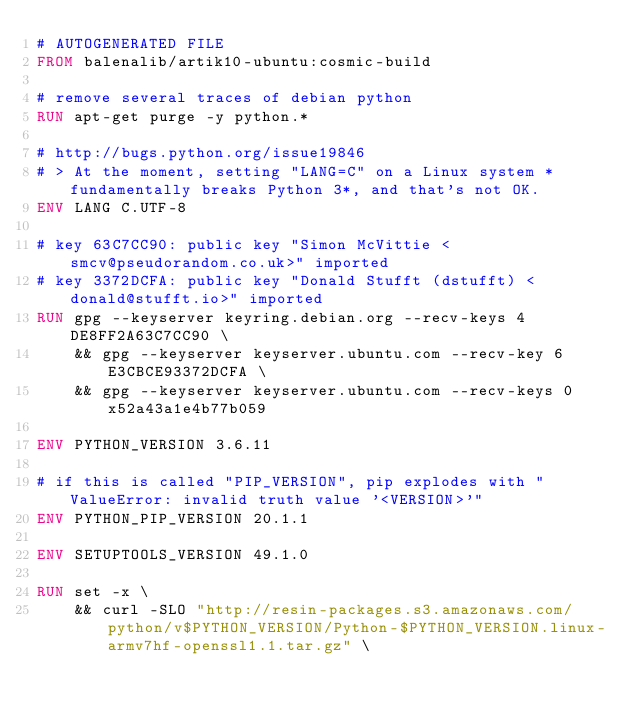Convert code to text. <code><loc_0><loc_0><loc_500><loc_500><_Dockerfile_># AUTOGENERATED FILE
FROM balenalib/artik10-ubuntu:cosmic-build

# remove several traces of debian python
RUN apt-get purge -y python.*

# http://bugs.python.org/issue19846
# > At the moment, setting "LANG=C" on a Linux system *fundamentally breaks Python 3*, and that's not OK.
ENV LANG C.UTF-8

# key 63C7CC90: public key "Simon McVittie <smcv@pseudorandom.co.uk>" imported
# key 3372DCFA: public key "Donald Stufft (dstufft) <donald@stufft.io>" imported
RUN gpg --keyserver keyring.debian.org --recv-keys 4DE8FF2A63C7CC90 \
	&& gpg --keyserver keyserver.ubuntu.com --recv-key 6E3CBCE93372DCFA \
	&& gpg --keyserver keyserver.ubuntu.com --recv-keys 0x52a43a1e4b77b059

ENV PYTHON_VERSION 3.6.11

# if this is called "PIP_VERSION", pip explodes with "ValueError: invalid truth value '<VERSION>'"
ENV PYTHON_PIP_VERSION 20.1.1

ENV SETUPTOOLS_VERSION 49.1.0

RUN set -x \
	&& curl -SLO "http://resin-packages.s3.amazonaws.com/python/v$PYTHON_VERSION/Python-$PYTHON_VERSION.linux-armv7hf-openssl1.1.tar.gz" \</code> 